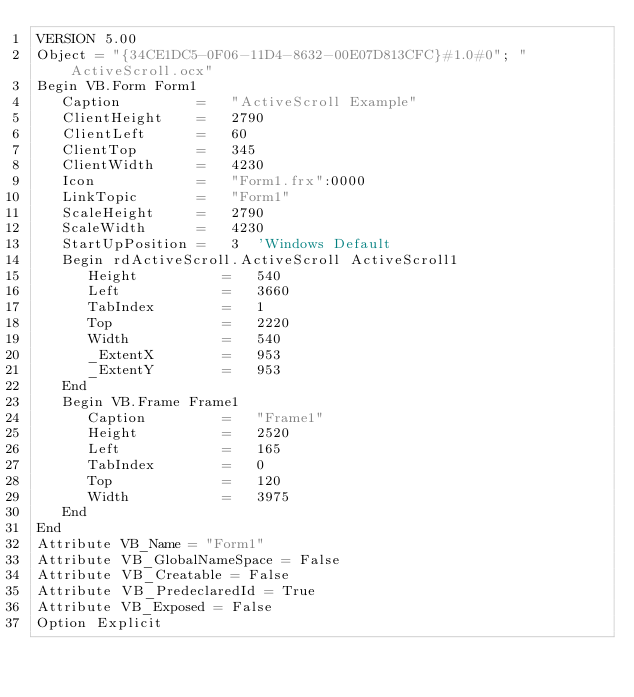<code> <loc_0><loc_0><loc_500><loc_500><_VisualBasic_>VERSION 5.00
Object = "{34CE1DC5-0F06-11D4-8632-00E07D813CFC}#1.0#0"; "ActiveScroll.ocx"
Begin VB.Form Form1 
   Caption         =   "ActiveScroll Example"
   ClientHeight    =   2790
   ClientLeft      =   60
   ClientTop       =   345
   ClientWidth     =   4230
   Icon            =   "Form1.frx":0000
   LinkTopic       =   "Form1"
   ScaleHeight     =   2790
   ScaleWidth      =   4230
   StartUpPosition =   3  'Windows Default
   Begin rdActiveScroll.ActiveScroll ActiveScroll1 
      Height          =   540
      Left            =   3660
      TabIndex        =   1
      Top             =   2220
      Width           =   540
      _ExtentX        =   953
      _ExtentY        =   953
   End
   Begin VB.Frame Frame1 
      Caption         =   "Frame1"
      Height          =   2520
      Left            =   165
      TabIndex        =   0
      Top             =   120
      Width           =   3975
   End
End
Attribute VB_Name = "Form1"
Attribute VB_GlobalNameSpace = False
Attribute VB_Creatable = False
Attribute VB_PredeclaredId = True
Attribute VB_Exposed = False
Option Explicit

</code> 